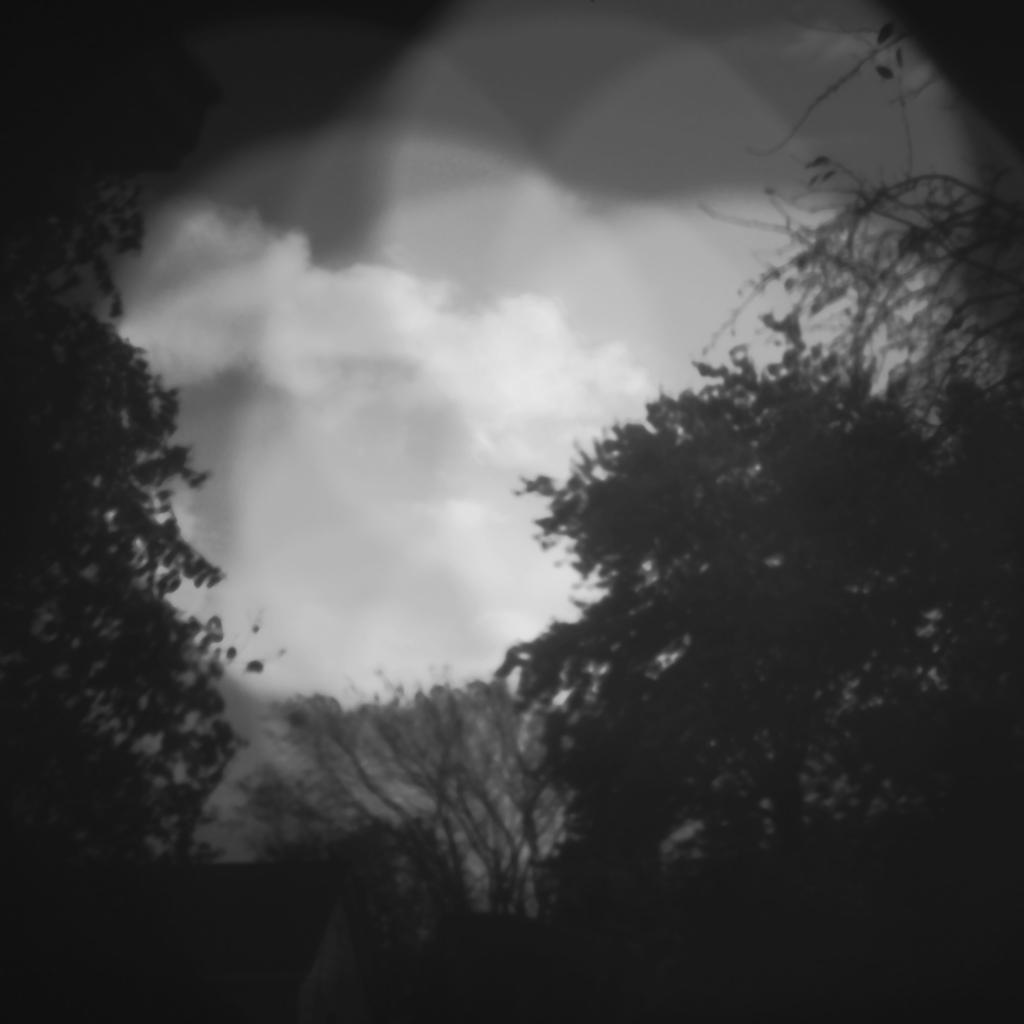What is the color scheme of the image? The image is black and white. What type of natural elements can be seen in the image? There are trees in the image. What part of the natural environment is visible in the image? Sky is visible in the image. What can be observed in the sky in the image? Clouds are present in the sky. What type of rhythm can be heard coming from the park in the image? There is no park present in the image, and therefore no rhythm can be heard. 